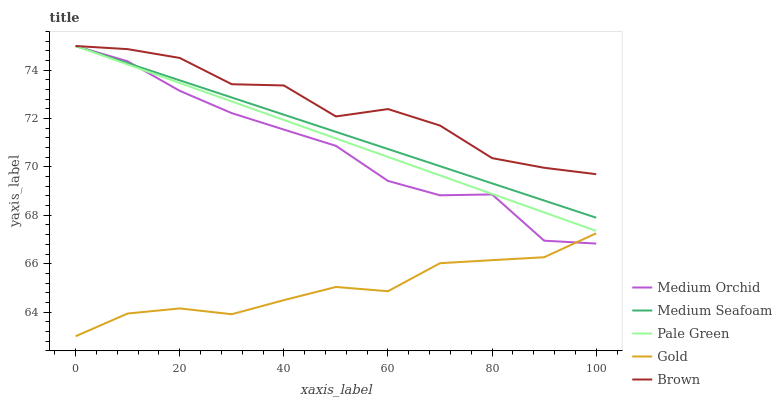Does Medium Orchid have the minimum area under the curve?
Answer yes or no. No. Does Medium Orchid have the maximum area under the curve?
Answer yes or no. No. Is Medium Orchid the smoothest?
Answer yes or no. No. Is Medium Orchid the roughest?
Answer yes or no. No. Does Medium Orchid have the lowest value?
Answer yes or no. No. Does Gold have the highest value?
Answer yes or no. No. Is Gold less than Brown?
Answer yes or no. Yes. Is Brown greater than Gold?
Answer yes or no. Yes. Does Gold intersect Brown?
Answer yes or no. No. 